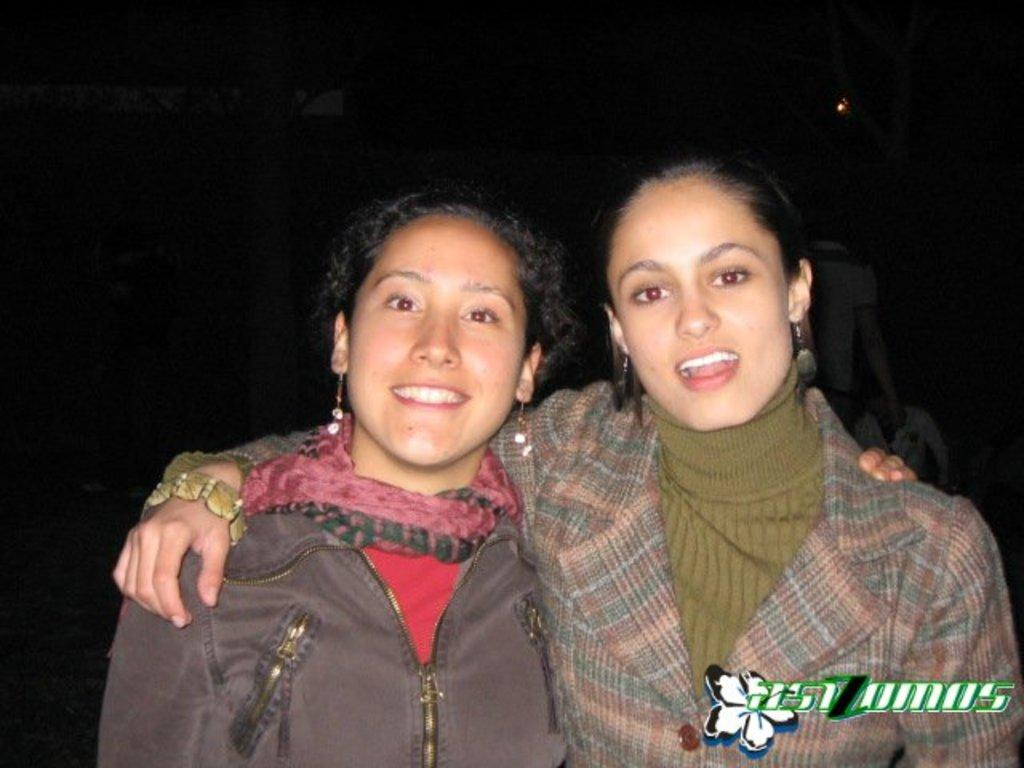Who are the main subjects in the image? There are two ladies in the center of the image. What are the ladies doing in the image? The ladies are standing and smiling. Can you describe the people in the background of the image? There are people in the background of the image, but their specific actions or appearances are not mentioned in the provided facts. What is the chance of winning the quarter in the image? There is no mention of a quarter or any game of chance in the image, so it is not possible to determine the odds of winning. 